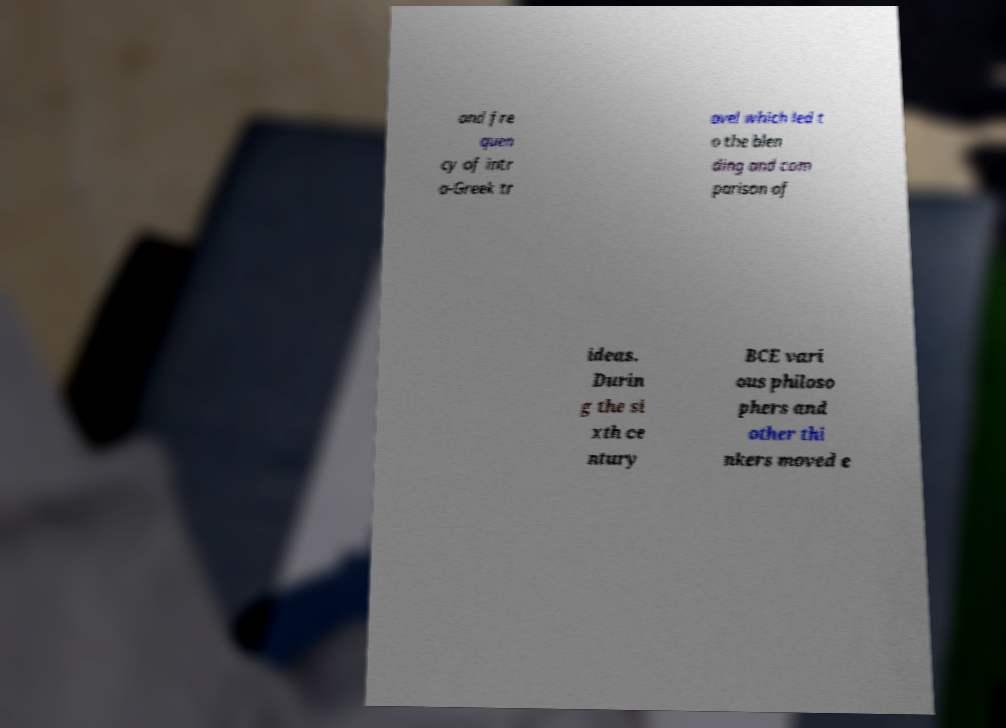Could you assist in decoding the text presented in this image and type it out clearly? and fre quen cy of intr a-Greek tr avel which led t o the blen ding and com parison of ideas. Durin g the si xth ce ntury BCE vari ous philoso phers and other thi nkers moved e 